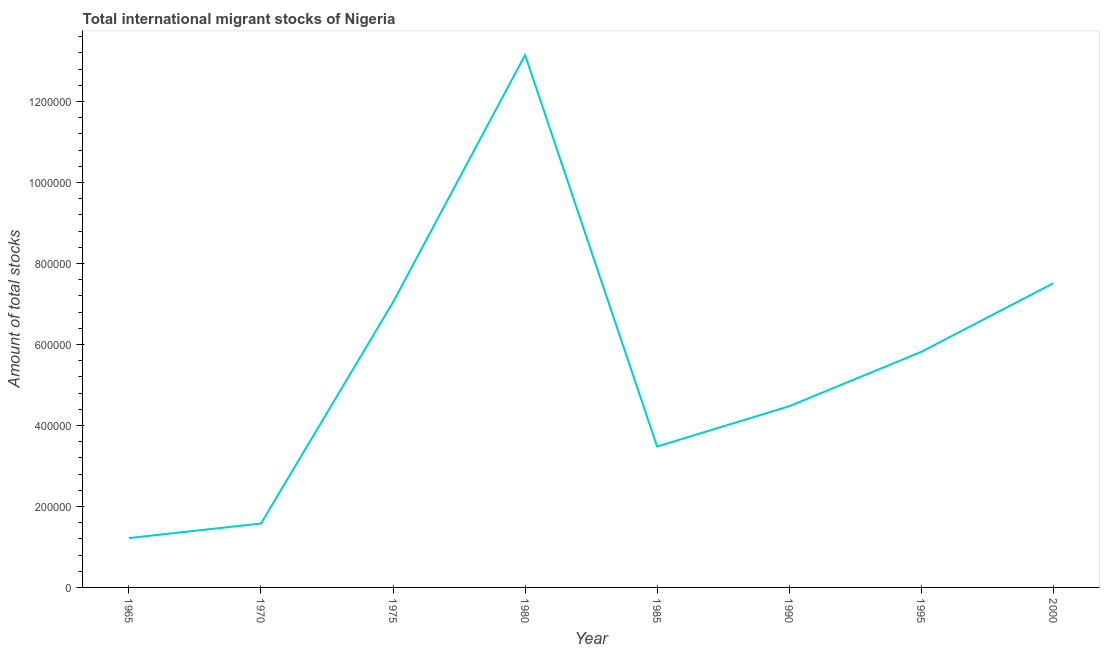What is the total number of international migrant stock in 2000?
Offer a terse response. 7.51e+05. Across all years, what is the maximum total number of international migrant stock?
Your answer should be very brief. 1.31e+06. Across all years, what is the minimum total number of international migrant stock?
Your response must be concise. 1.22e+05. In which year was the total number of international migrant stock minimum?
Make the answer very short. 1965. What is the sum of the total number of international migrant stock?
Provide a succinct answer. 4.43e+06. What is the difference between the total number of international migrant stock in 1970 and 1975?
Make the answer very short. -5.47e+05. What is the average total number of international migrant stock per year?
Make the answer very short. 5.53e+05. What is the median total number of international migrant stock?
Provide a short and direct response. 5.15e+05. What is the ratio of the total number of international migrant stock in 1970 to that in 1995?
Provide a short and direct response. 0.27. What is the difference between the highest and the second highest total number of international migrant stock?
Give a very brief answer. 5.64e+05. Is the sum of the total number of international migrant stock in 1965 and 1975 greater than the maximum total number of international migrant stock across all years?
Give a very brief answer. No. What is the difference between the highest and the lowest total number of international migrant stock?
Keep it short and to the point. 1.19e+06. How many years are there in the graph?
Provide a short and direct response. 8. Does the graph contain any zero values?
Keep it short and to the point. No. What is the title of the graph?
Provide a succinct answer. Total international migrant stocks of Nigeria. What is the label or title of the X-axis?
Your response must be concise. Year. What is the label or title of the Y-axis?
Provide a short and direct response. Amount of total stocks. What is the Amount of total stocks in 1965?
Your answer should be compact. 1.22e+05. What is the Amount of total stocks of 1970?
Your answer should be compact. 1.58e+05. What is the Amount of total stocks of 1975?
Provide a short and direct response. 7.04e+05. What is the Amount of total stocks in 1980?
Make the answer very short. 1.31e+06. What is the Amount of total stocks of 1985?
Make the answer very short. 3.48e+05. What is the Amount of total stocks in 1990?
Provide a succinct answer. 4.47e+05. What is the Amount of total stocks of 1995?
Ensure brevity in your answer.  5.82e+05. What is the Amount of total stocks of 2000?
Offer a very short reply. 7.51e+05. What is the difference between the Amount of total stocks in 1965 and 1970?
Your answer should be very brief. -3.59e+04. What is the difference between the Amount of total stocks in 1965 and 1975?
Provide a short and direct response. -5.82e+05. What is the difference between the Amount of total stocks in 1965 and 1980?
Give a very brief answer. -1.19e+06. What is the difference between the Amount of total stocks in 1965 and 1985?
Provide a short and direct response. -2.26e+05. What is the difference between the Amount of total stocks in 1965 and 1990?
Make the answer very short. -3.26e+05. What is the difference between the Amount of total stocks in 1965 and 1995?
Make the answer very short. -4.60e+05. What is the difference between the Amount of total stocks in 1965 and 2000?
Make the answer very short. -6.29e+05. What is the difference between the Amount of total stocks in 1970 and 1975?
Make the answer very short. -5.47e+05. What is the difference between the Amount of total stocks in 1970 and 1980?
Your answer should be compact. -1.16e+06. What is the difference between the Amount of total stocks in 1970 and 1985?
Make the answer very short. -1.90e+05. What is the difference between the Amount of total stocks in 1970 and 1990?
Offer a terse response. -2.90e+05. What is the difference between the Amount of total stocks in 1970 and 1995?
Offer a very short reply. -4.24e+05. What is the difference between the Amount of total stocks in 1970 and 2000?
Ensure brevity in your answer.  -5.93e+05. What is the difference between the Amount of total stocks in 1975 and 1980?
Make the answer very short. -6.10e+05. What is the difference between the Amount of total stocks in 1975 and 1985?
Your response must be concise. 3.56e+05. What is the difference between the Amount of total stocks in 1975 and 1990?
Provide a short and direct response. 2.57e+05. What is the difference between the Amount of total stocks in 1975 and 1995?
Give a very brief answer. 1.23e+05. What is the difference between the Amount of total stocks in 1975 and 2000?
Ensure brevity in your answer.  -4.67e+04. What is the difference between the Amount of total stocks in 1980 and 1985?
Your answer should be very brief. 9.67e+05. What is the difference between the Amount of total stocks in 1980 and 1990?
Your answer should be very brief. 8.67e+05. What is the difference between the Amount of total stocks in 1980 and 1995?
Offer a terse response. 7.33e+05. What is the difference between the Amount of total stocks in 1980 and 2000?
Provide a short and direct response. 5.64e+05. What is the difference between the Amount of total stocks in 1985 and 1990?
Offer a terse response. -9.95e+04. What is the difference between the Amount of total stocks in 1985 and 1995?
Keep it short and to the point. -2.34e+05. What is the difference between the Amount of total stocks in 1985 and 2000?
Offer a very short reply. -4.03e+05. What is the difference between the Amount of total stocks in 1990 and 1995?
Give a very brief answer. -1.34e+05. What is the difference between the Amount of total stocks in 1990 and 2000?
Your answer should be compact. -3.04e+05. What is the difference between the Amount of total stocks in 1995 and 2000?
Your response must be concise. -1.69e+05. What is the ratio of the Amount of total stocks in 1965 to that in 1970?
Make the answer very short. 0.77. What is the ratio of the Amount of total stocks in 1965 to that in 1975?
Your response must be concise. 0.17. What is the ratio of the Amount of total stocks in 1965 to that in 1980?
Provide a succinct answer. 0.09. What is the ratio of the Amount of total stocks in 1965 to that in 1985?
Offer a terse response. 0.35. What is the ratio of the Amount of total stocks in 1965 to that in 1990?
Provide a short and direct response. 0.27. What is the ratio of the Amount of total stocks in 1965 to that in 1995?
Your answer should be very brief. 0.21. What is the ratio of the Amount of total stocks in 1965 to that in 2000?
Your answer should be compact. 0.16. What is the ratio of the Amount of total stocks in 1970 to that in 1975?
Provide a succinct answer. 0.22. What is the ratio of the Amount of total stocks in 1970 to that in 1980?
Your answer should be compact. 0.12. What is the ratio of the Amount of total stocks in 1970 to that in 1985?
Provide a succinct answer. 0.45. What is the ratio of the Amount of total stocks in 1970 to that in 1990?
Offer a very short reply. 0.35. What is the ratio of the Amount of total stocks in 1970 to that in 1995?
Provide a succinct answer. 0.27. What is the ratio of the Amount of total stocks in 1970 to that in 2000?
Offer a terse response. 0.21. What is the ratio of the Amount of total stocks in 1975 to that in 1980?
Your answer should be very brief. 0.54. What is the ratio of the Amount of total stocks in 1975 to that in 1985?
Keep it short and to the point. 2.02. What is the ratio of the Amount of total stocks in 1975 to that in 1990?
Provide a succinct answer. 1.57. What is the ratio of the Amount of total stocks in 1975 to that in 1995?
Provide a short and direct response. 1.21. What is the ratio of the Amount of total stocks in 1975 to that in 2000?
Your response must be concise. 0.94. What is the ratio of the Amount of total stocks in 1980 to that in 1985?
Your answer should be very brief. 3.78. What is the ratio of the Amount of total stocks in 1980 to that in 1990?
Give a very brief answer. 2.94. What is the ratio of the Amount of total stocks in 1980 to that in 1995?
Keep it short and to the point. 2.26. What is the ratio of the Amount of total stocks in 1985 to that in 1990?
Keep it short and to the point. 0.78. What is the ratio of the Amount of total stocks in 1985 to that in 1995?
Your response must be concise. 0.6. What is the ratio of the Amount of total stocks in 1985 to that in 2000?
Provide a short and direct response. 0.46. What is the ratio of the Amount of total stocks in 1990 to that in 1995?
Offer a very short reply. 0.77. What is the ratio of the Amount of total stocks in 1990 to that in 2000?
Offer a terse response. 0.6. What is the ratio of the Amount of total stocks in 1995 to that in 2000?
Your response must be concise. 0.77. 